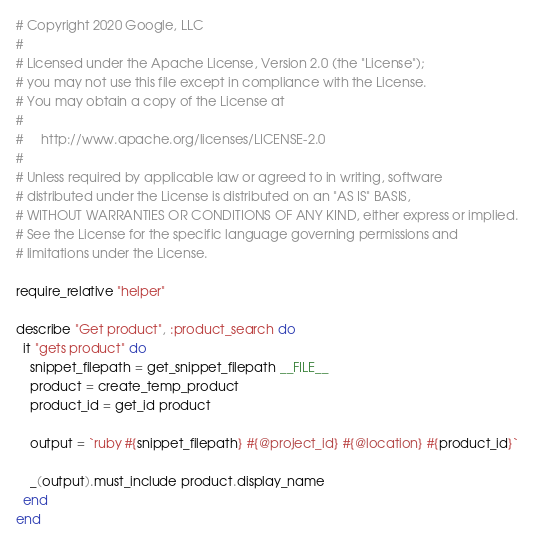Convert code to text. <code><loc_0><loc_0><loc_500><loc_500><_Ruby_># Copyright 2020 Google, LLC
#
# Licensed under the Apache License, Version 2.0 (the "License");
# you may not use this file except in compliance with the License.
# You may obtain a copy of the License at
#
#     http://www.apache.org/licenses/LICENSE-2.0
#
# Unless required by applicable law or agreed to in writing, software
# distributed under the License is distributed on an "AS IS" BASIS,
# WITHOUT WARRANTIES OR CONDITIONS OF ANY KIND, either express or implied.
# See the License for the specific language governing permissions and
# limitations under the License.

require_relative "helper"

describe "Get product", :product_search do
  it "gets product" do
    snippet_filepath = get_snippet_filepath __FILE__
    product = create_temp_product
    product_id = get_id product

    output = `ruby #{snippet_filepath} #{@project_id} #{@location} #{product_id}`

    _(output).must_include product.display_name
  end
end
</code> 